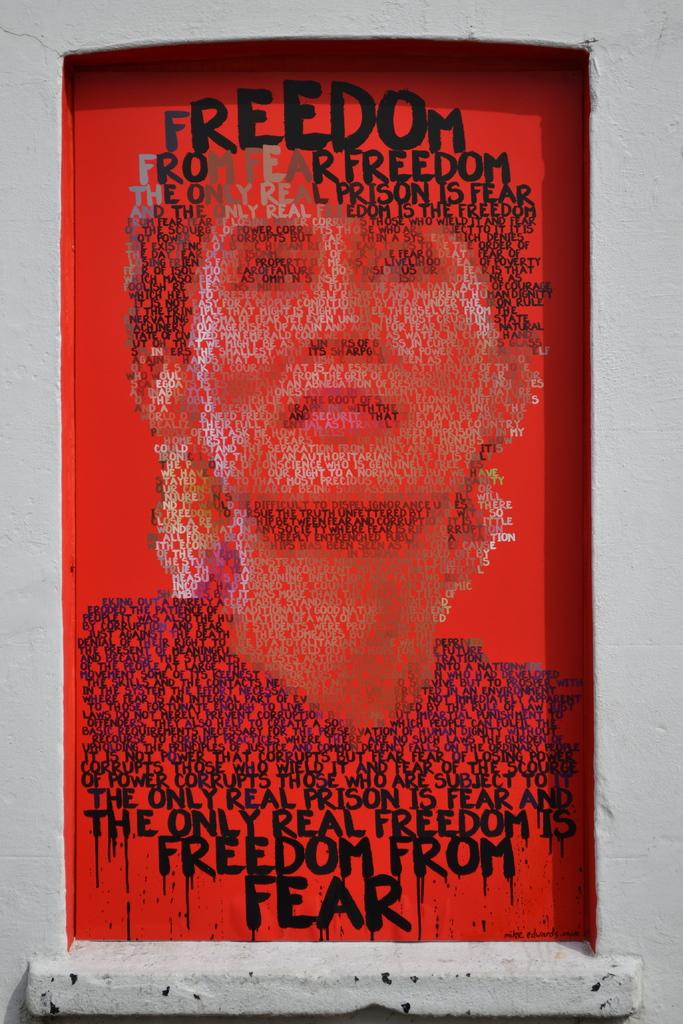What is the main subject of the image? There is a beautiful painting in the image. What is depicted in the painting? The painting features a person. Are there any words or letters on the painting? Yes, there is text written on the painting. What color is the background of the painting? The background of the painting is red in color. What type of whistle can be heard in the image? There is no whistle present in the image, as it is a painting and does not produce sound. 